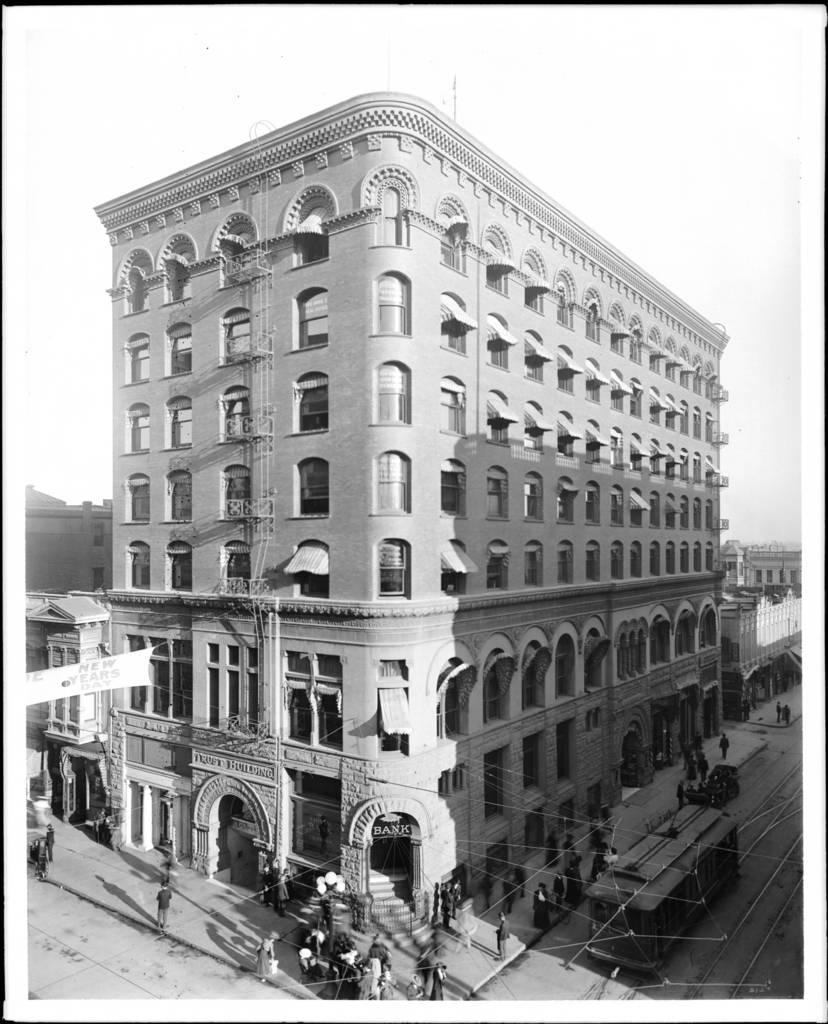What is located in the center of the image? There are persons and vehicles in the center of the image. Can you describe the people in the image? The provided facts do not give specific details about the people in the image. What can be seen in the background of the image? There are buildings in the background of the image. What type of body is visible in the image? There is no specific body visible in the image; it features persons and vehicles. Can you tell me how many buttons are present in the image? There is no reference to any buttons in the provided facts, so it cannot be determined from the image. 